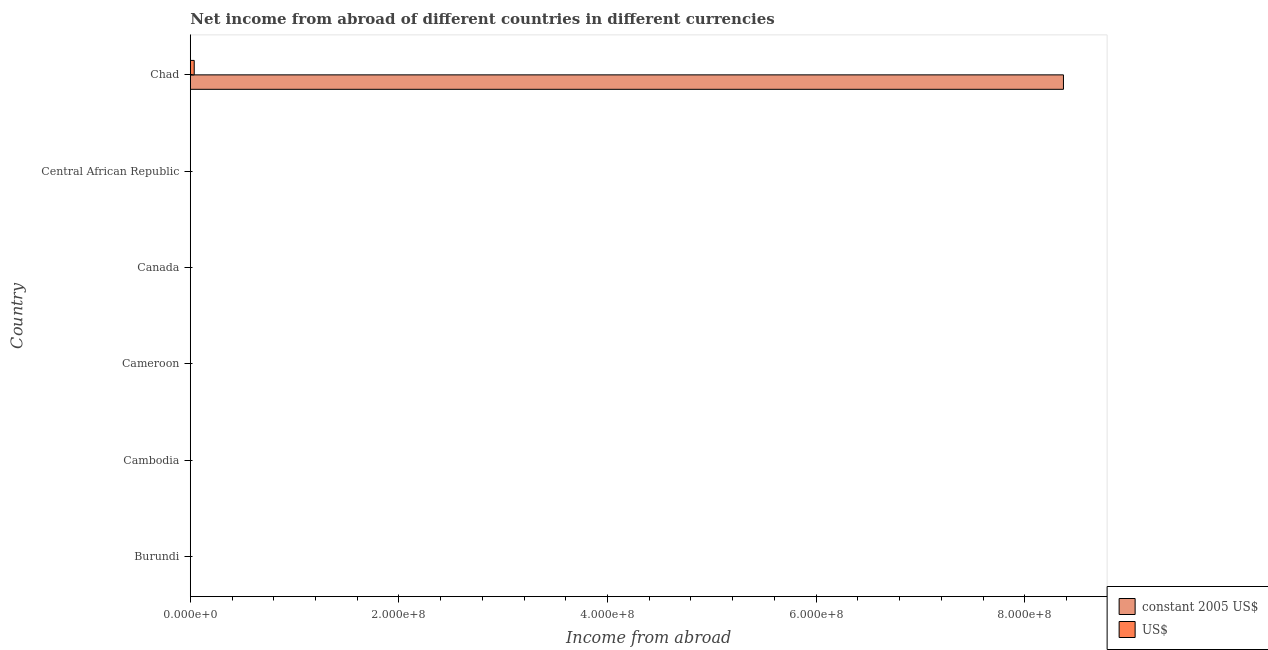How many bars are there on the 3rd tick from the bottom?
Give a very brief answer. 0. What is the label of the 4th group of bars from the top?
Your response must be concise. Cameroon. What is the income from abroad in constant 2005 us$ in Cameroon?
Offer a terse response. 0. Across all countries, what is the maximum income from abroad in constant 2005 us$?
Offer a terse response. 8.37e+08. In which country was the income from abroad in constant 2005 us$ maximum?
Keep it short and to the point. Chad. What is the total income from abroad in us$ in the graph?
Your answer should be very brief. 3.76e+06. What is the difference between the income from abroad in us$ in Canada and the income from abroad in constant 2005 us$ in Chad?
Provide a succinct answer. -8.37e+08. What is the average income from abroad in constant 2005 us$ per country?
Offer a very short reply. 1.40e+08. What is the difference between the income from abroad in constant 2005 us$ and income from abroad in us$ in Chad?
Provide a succinct answer. 8.33e+08. What is the difference between the highest and the lowest income from abroad in constant 2005 us$?
Make the answer very short. 8.37e+08. Are all the bars in the graph horizontal?
Make the answer very short. Yes. What is the difference between two consecutive major ticks on the X-axis?
Your answer should be very brief. 2.00e+08. Are the values on the major ticks of X-axis written in scientific E-notation?
Offer a very short reply. Yes. Does the graph contain any zero values?
Provide a short and direct response. Yes. Where does the legend appear in the graph?
Offer a very short reply. Bottom right. What is the title of the graph?
Provide a succinct answer. Net income from abroad of different countries in different currencies. What is the label or title of the X-axis?
Keep it short and to the point. Income from abroad. What is the Income from abroad in US$ in Burundi?
Give a very brief answer. 0. What is the Income from abroad in constant 2005 US$ in Cambodia?
Give a very brief answer. 0. What is the Income from abroad in US$ in Cambodia?
Provide a succinct answer. 0. What is the Income from abroad of constant 2005 US$ in Cameroon?
Give a very brief answer. 0. What is the Income from abroad in constant 2005 US$ in Canada?
Your answer should be very brief. 0. What is the Income from abroad in constant 2005 US$ in Central African Republic?
Keep it short and to the point. 0. What is the Income from abroad of constant 2005 US$ in Chad?
Offer a terse response. 8.37e+08. What is the Income from abroad in US$ in Chad?
Provide a succinct answer. 3.76e+06. Across all countries, what is the maximum Income from abroad of constant 2005 US$?
Ensure brevity in your answer.  8.37e+08. Across all countries, what is the maximum Income from abroad in US$?
Your response must be concise. 3.76e+06. Across all countries, what is the minimum Income from abroad in US$?
Provide a succinct answer. 0. What is the total Income from abroad of constant 2005 US$ in the graph?
Your answer should be very brief. 8.37e+08. What is the total Income from abroad of US$ in the graph?
Provide a succinct answer. 3.76e+06. What is the average Income from abroad in constant 2005 US$ per country?
Offer a terse response. 1.40e+08. What is the average Income from abroad of US$ per country?
Provide a short and direct response. 6.26e+05. What is the difference between the Income from abroad of constant 2005 US$ and Income from abroad of US$ in Chad?
Provide a short and direct response. 8.33e+08. What is the difference between the highest and the lowest Income from abroad of constant 2005 US$?
Provide a short and direct response. 8.37e+08. What is the difference between the highest and the lowest Income from abroad of US$?
Offer a very short reply. 3.76e+06. 